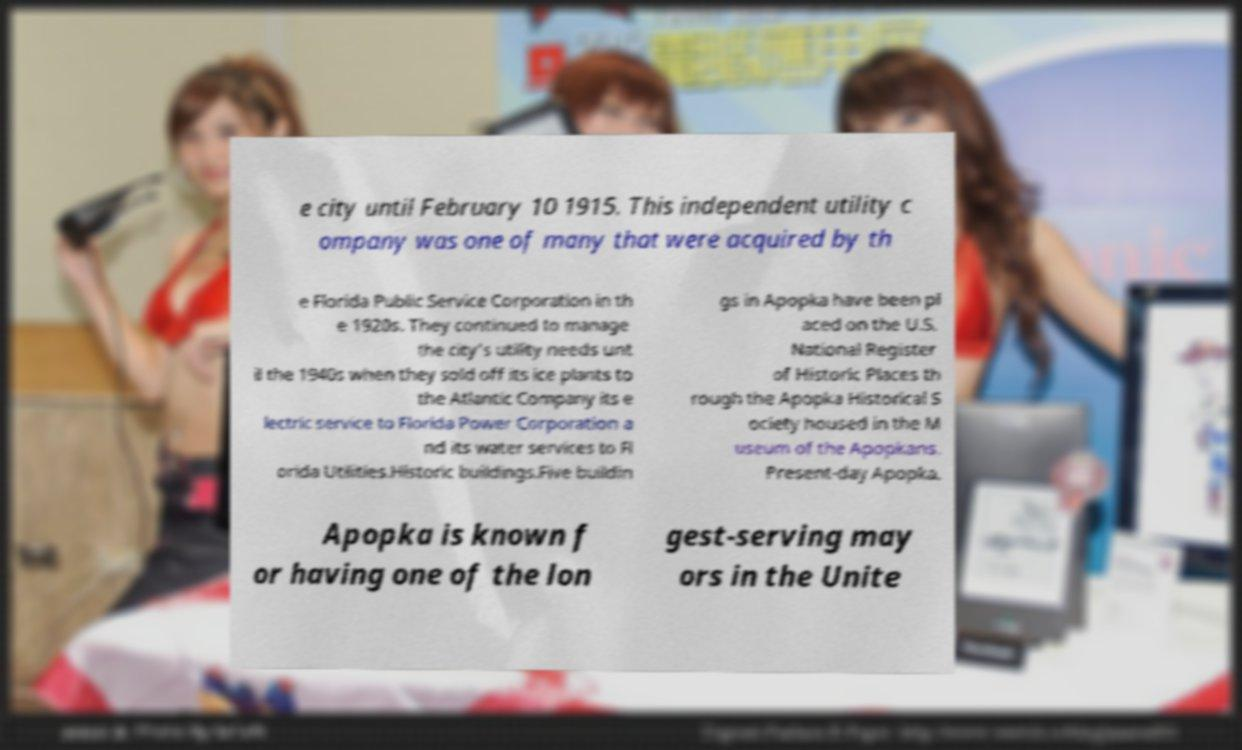Please read and relay the text visible in this image. What does it say? e city until February 10 1915. This independent utility c ompany was one of many that were acquired by th e Florida Public Service Corporation in th e 1920s. They continued to manage the city's utility needs unt il the 1940s when they sold off its ice plants to the Atlantic Company its e lectric service to Florida Power Corporation a nd its water services to Fl orida Utilities.Historic buildings.Five buildin gs in Apopka have been pl aced on the U.S. National Register of Historic Places th rough the Apopka Historical S ociety housed in the M useum of the Apopkans. Present-day Apopka. Apopka is known f or having one of the lon gest-serving may ors in the Unite 